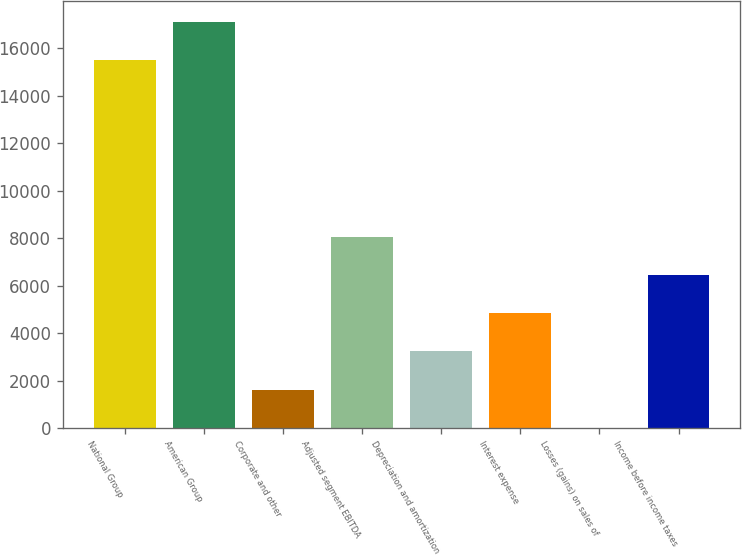<chart> <loc_0><loc_0><loc_500><loc_500><bar_chart><fcel>National Group<fcel>American Group<fcel>Corporate and other<fcel>Adjusted segment EBITDA<fcel>Depreciation and amortization<fcel>Interest expense<fcel>Losses (gains) on sales of<fcel>Income before income taxes<nl><fcel>15505<fcel>17115<fcel>1625<fcel>8065<fcel>3235<fcel>4845<fcel>15<fcel>6455<nl></chart> 